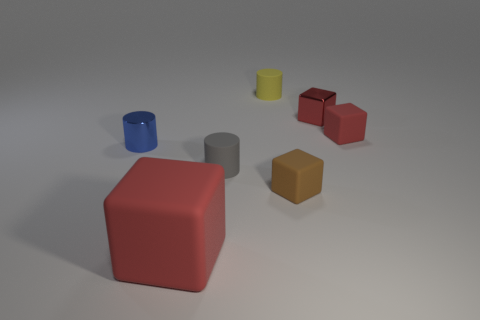What number of small things are purple metal balls or red matte cubes?
Your response must be concise. 1. How many gray cylinders are there?
Provide a short and direct response. 1. What is the small red object right of the small red metallic block made of?
Your answer should be compact. Rubber. There is a small blue shiny cylinder; are there any tiny cylinders behind it?
Provide a short and direct response. Yes. How many tiny red spheres are the same material as the large red block?
Your answer should be very brief. 0. What is the size of the red rubber thing that is in front of the shiny object to the left of the brown matte thing?
Your answer should be compact. Large. The rubber cube that is to the right of the big red block and in front of the small red matte thing is what color?
Give a very brief answer. Brown. Does the tiny gray object have the same shape as the tiny blue metallic thing?
Give a very brief answer. Yes. There is a shiny thing that is in front of the cube to the right of the red metallic cube; what shape is it?
Your response must be concise. Cylinder. Does the small red shiny object have the same shape as the red matte thing that is behind the big red object?
Your response must be concise. Yes. 